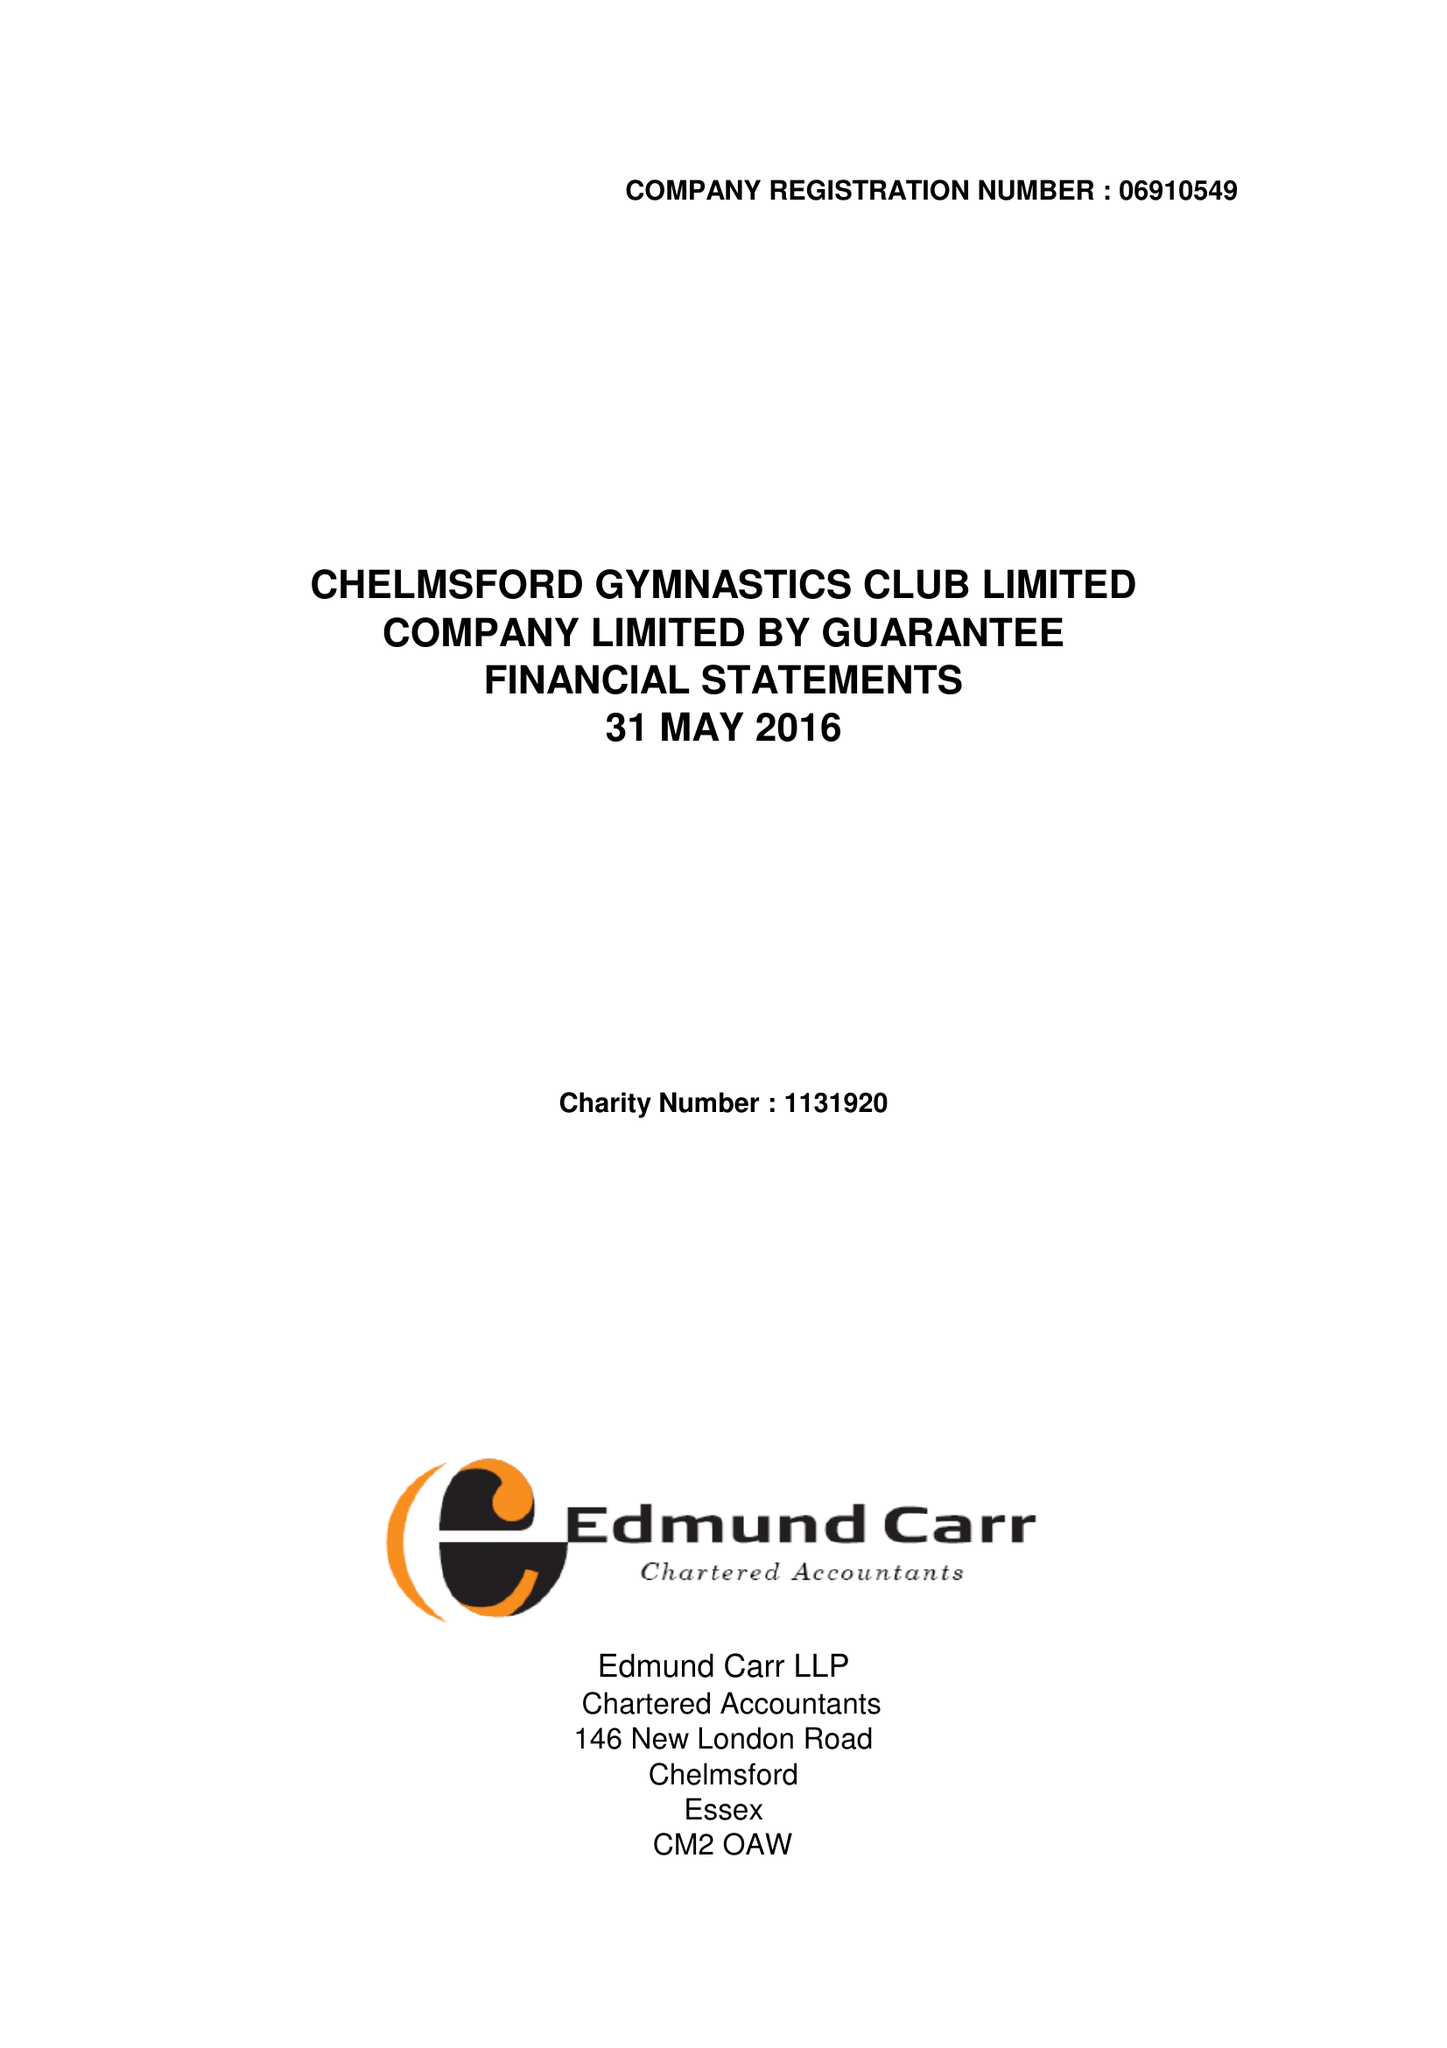What is the value for the charity_number?
Answer the question using a single word or phrase. 1131920 